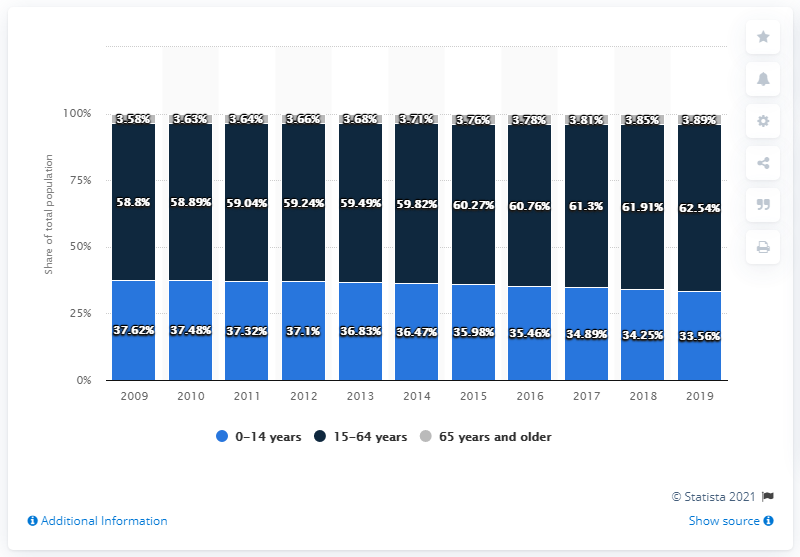Highlight a few significant elements in this photo. The average age of the population between 15-64 years and 65 years in 2019 was 33.215 years. The difference between the shortest light blue bar and the tallest grey bar is 29.67. 